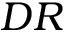Convert formula to latex. <formula><loc_0><loc_0><loc_500><loc_500>{ D R }</formula> 